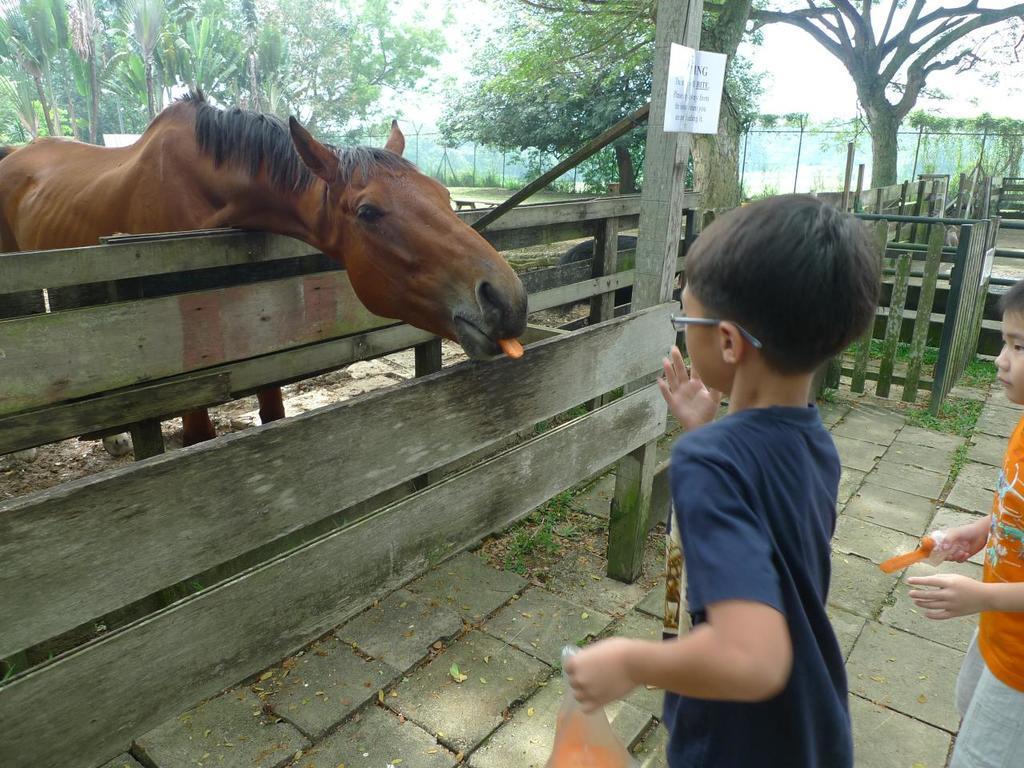In one or two sentences, can you explain what this image depicts? In this image we can see one horse and two children are standing. One child is wearing purple color t-shirt and holding one cover full of carrot and the other one is wearing orange color t-shirt with white shorts and he is also holding a piece of carrot. Background of the image we can see trees and fence. In front of the horse one wooden fence is there, to the wooden fence one board is attached. 